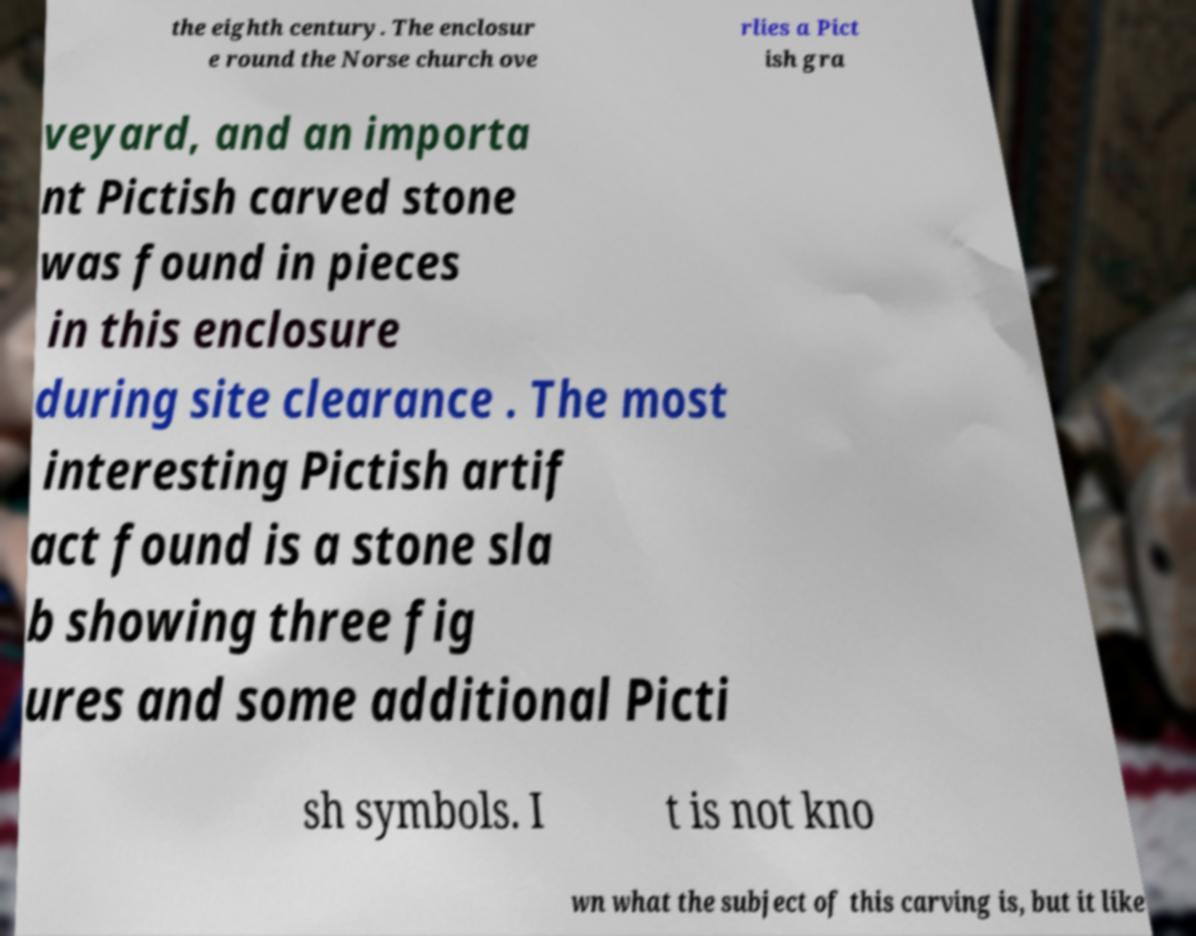There's text embedded in this image that I need extracted. Can you transcribe it verbatim? the eighth century. The enclosur e round the Norse church ove rlies a Pict ish gra veyard, and an importa nt Pictish carved stone was found in pieces in this enclosure during site clearance . The most interesting Pictish artif act found is a stone sla b showing three fig ures and some additional Picti sh symbols. I t is not kno wn what the subject of this carving is, but it like 